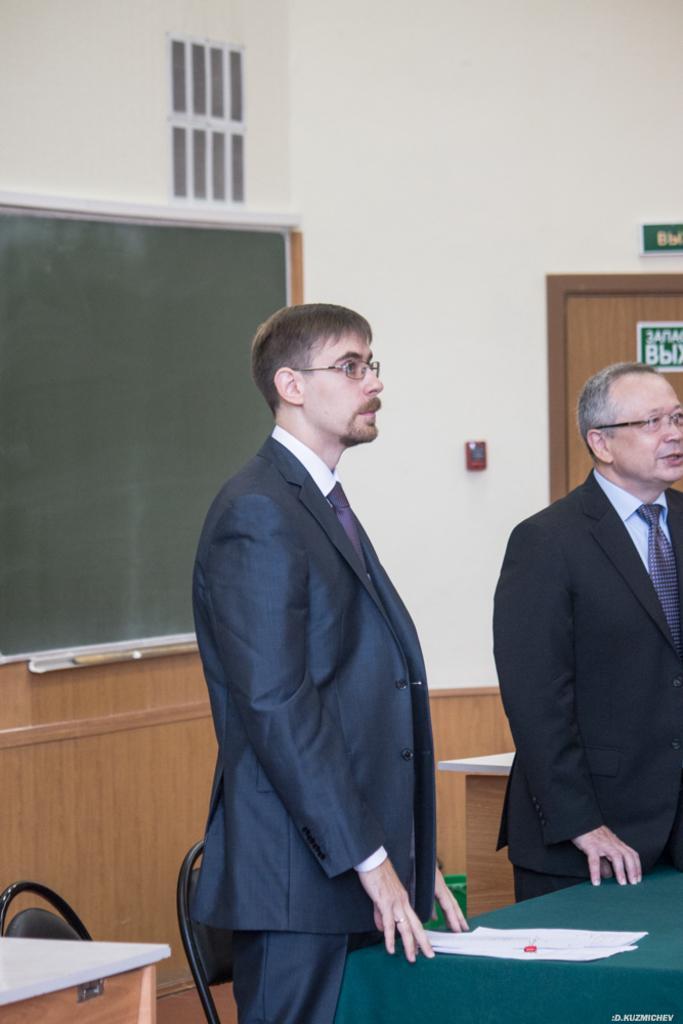In one or two sentences, can you explain what this image depicts? In this picture we can see two persons are standing on the floor. These are the chairs and there is a table. On the background there is a wall and this is board. Here we can see a door. 